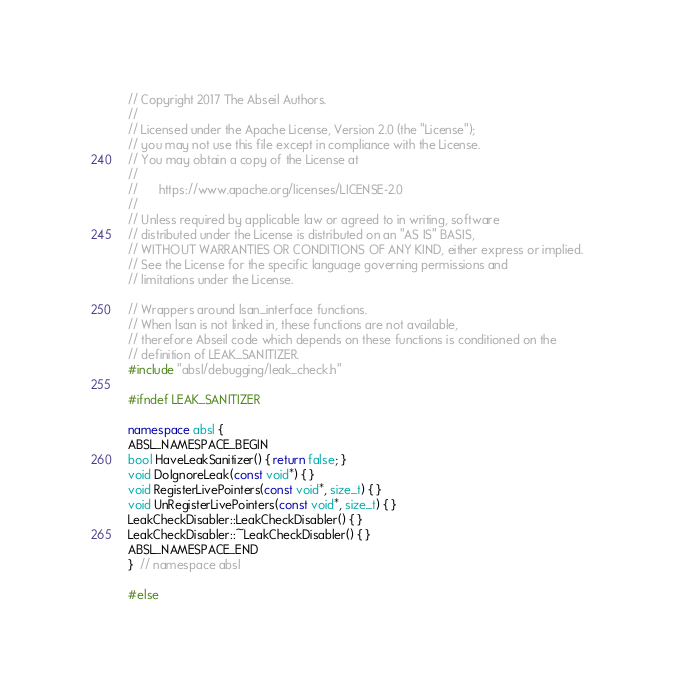<code> <loc_0><loc_0><loc_500><loc_500><_C++_>// Copyright 2017 The Abseil Authors.
//
// Licensed under the Apache License, Version 2.0 (the "License");
// you may not use this file except in compliance with the License.
// You may obtain a copy of the License at
//
//      https://www.apache.org/licenses/LICENSE-2.0
//
// Unless required by applicable law or agreed to in writing, software
// distributed under the License is distributed on an "AS IS" BASIS,
// WITHOUT WARRANTIES OR CONDITIONS OF ANY KIND, either express or implied.
// See the License for the specific language governing permissions and
// limitations under the License.

// Wrappers around lsan_interface functions.
// When lsan is not linked in, these functions are not available,
// therefore Abseil code which depends on these functions is conditioned on the
// definition of LEAK_SANITIZER.
#include "absl/debugging/leak_check.h"

#ifndef LEAK_SANITIZER

namespace absl {
ABSL_NAMESPACE_BEGIN
bool HaveLeakSanitizer() { return false; }
void DoIgnoreLeak(const void*) { }
void RegisterLivePointers(const void*, size_t) { }
void UnRegisterLivePointers(const void*, size_t) { }
LeakCheckDisabler::LeakCheckDisabler() { }
LeakCheckDisabler::~LeakCheckDisabler() { }
ABSL_NAMESPACE_END
}  // namespace absl

#else
</code> 